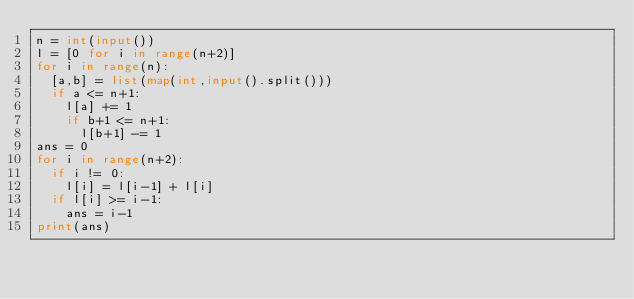Convert code to text. <code><loc_0><loc_0><loc_500><loc_500><_Python_>n = int(input())
l = [0 for i in range(n+2)]
for i in range(n):
  [a,b] = list(map(int,input().split()))
  if a <= n+1:
    l[a] += 1
    if b+1 <= n+1:
      l[b+1] -= 1
ans = 0
for i in range(n+2):
  if i != 0:
    l[i] = l[i-1] + l[i]
  if l[i] >= i-1:
    ans = i-1
print(ans)</code> 